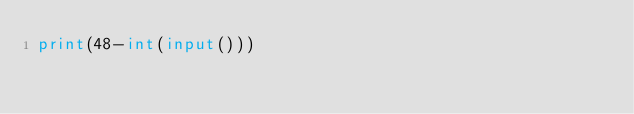<code> <loc_0><loc_0><loc_500><loc_500><_Python_>print(48-int(input()))</code> 